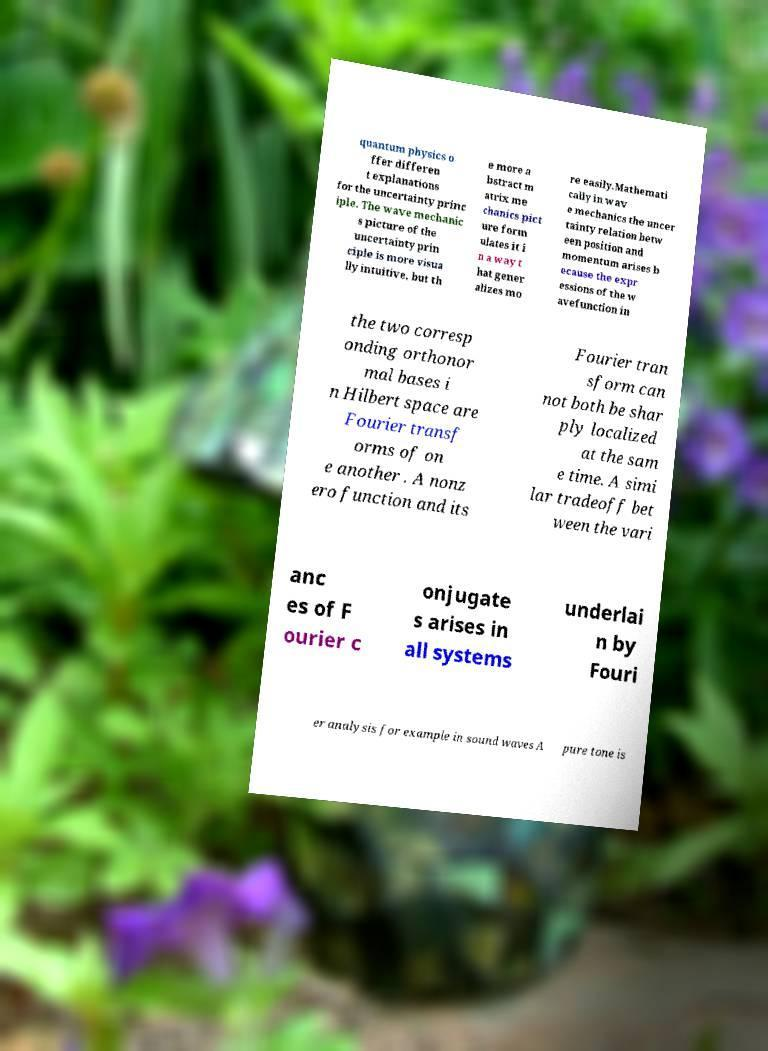Can you accurately transcribe the text from the provided image for me? quantum physics o ffer differen t explanations for the uncertainty princ iple. The wave mechanic s picture of the uncertainty prin ciple is more visua lly intuitive, but th e more a bstract m atrix me chanics pict ure form ulates it i n a way t hat gener alizes mo re easily.Mathemati cally in wav e mechanics the uncer tainty relation betw een position and momentum arises b ecause the expr essions of the w avefunction in the two corresp onding orthonor mal bases i n Hilbert space are Fourier transf orms of on e another . A nonz ero function and its Fourier tran sform can not both be shar ply localized at the sam e time. A simi lar tradeoff bet ween the vari anc es of F ourier c onjugate s arises in all systems underlai n by Fouri er analysis for example in sound waves A pure tone is 